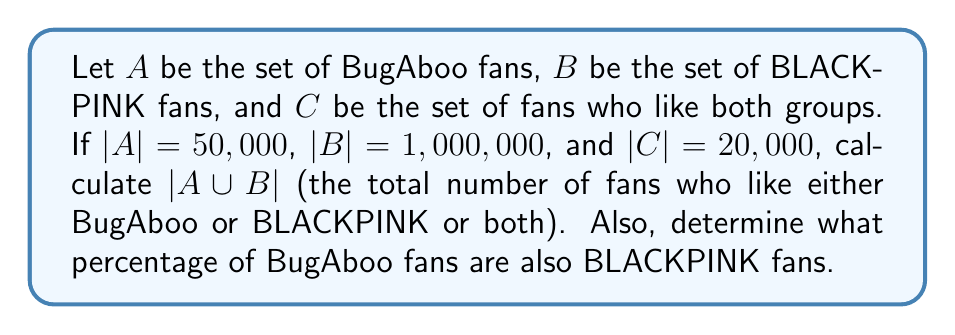Give your solution to this math problem. To solve this problem, we'll use set theory concepts and the inclusion-exclusion principle.

1. First, let's recall the formula for the union of two sets:
   $$|A \cup B| = |A| + |B| - |A \cap B|$$

2. We're given:
   $|A| = 50,000$ (BugAboo fans)
   $|B| = 1,000,000$ (BLACKPINK fans)
   $|C| = |A \cap B| = 20,000$ (fans of both groups)

3. Substituting these values into the formula:
   $$|A \cup B| = 50,000 + 1,000,000 - 20,000$$
   $$|A \cup B| = 1,030,000$$

4. To calculate the percentage of BugAboo fans who are also BLACKPINK fans:
   - Total BugAboo fans: $|A| = 50,000$
   - BugAboo fans who are also BLACKPINK fans: $|C| = 20,000$
   
   Percentage = $\frac{|C|}{|A|} \times 100\% = \frac{20,000}{50,000} \times 100\% = 40\%$
Answer: $|A \cup B| = 1,030,000$ fans
40% of BugAboo fans are also BLACKPINK fans 